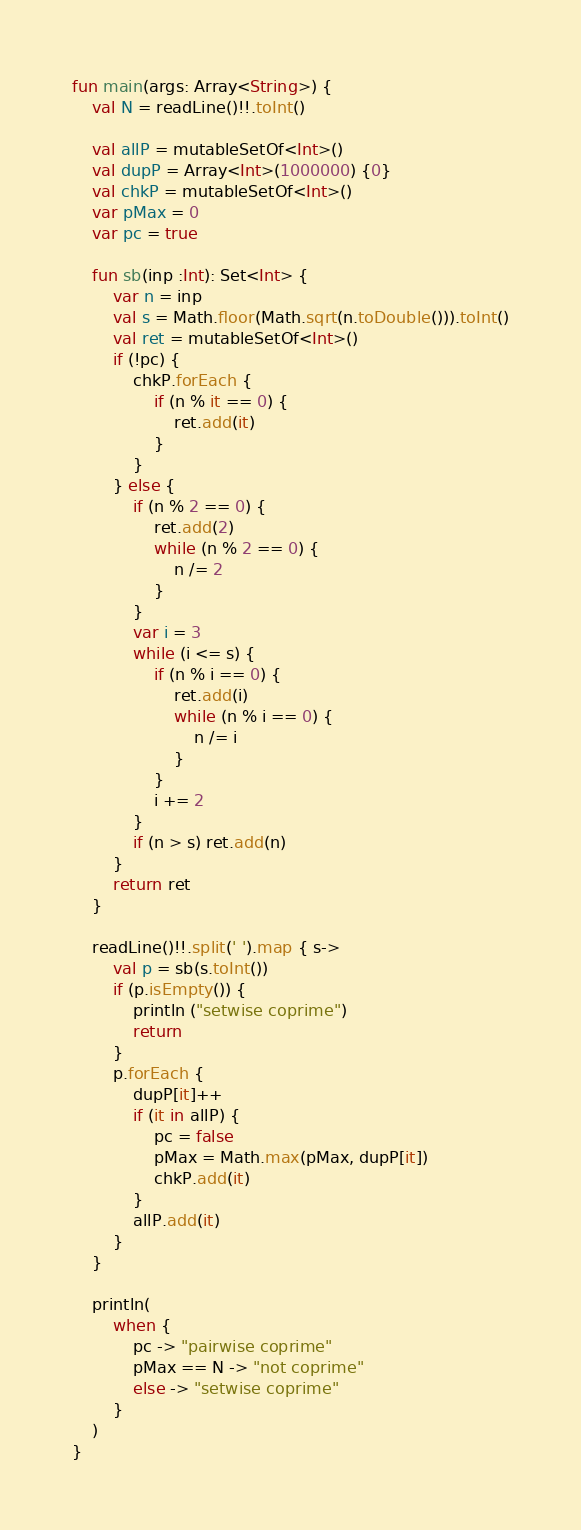Convert code to text. <code><loc_0><loc_0><loc_500><loc_500><_Kotlin_>fun main(args: Array<String>) {
    val N = readLine()!!.toInt()

    val allP = mutableSetOf<Int>()
    val dupP = Array<Int>(1000000) {0}
    val chkP = mutableSetOf<Int>()
    var pMax = 0
    var pc = true

    fun sb(inp :Int): Set<Int> {
        var n = inp
        val s = Math.floor(Math.sqrt(n.toDouble())).toInt()
        val ret = mutableSetOf<Int>()
        if (!pc) {
            chkP.forEach {
                if (n % it == 0) {
                    ret.add(it)
                }
            }
        } else {
            if (n % 2 == 0) {
                ret.add(2)
                while (n % 2 == 0) {
                    n /= 2
                }
            }
            var i = 3
            while (i <= s) {
                if (n % i == 0) {
                    ret.add(i)
                    while (n % i == 0) {
                        n /= i
                    }
                }
                i += 2
            }
            if (n > s) ret.add(n)
        }
        return ret
    }

    readLine()!!.split(' ').map { s->
        val p = sb(s.toInt())
        if (p.isEmpty()) {
            println ("setwise coprime")
            return
        }
        p.forEach {
            dupP[it]++
            if (it in allP) {
                pc = false
                pMax = Math.max(pMax, dupP[it])
                chkP.add(it)
            }
            allP.add(it)
        }
    }

    println(
        when {
            pc -> "pairwise coprime"
            pMax == N -> "not coprime"
            else -> "setwise coprime"
        }
    )
}
</code> 